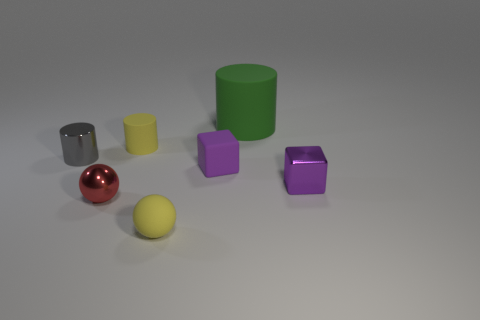Subtract all yellow rubber cylinders. How many cylinders are left? 2 Add 2 tiny purple rubber blocks. How many objects exist? 9 Subtract all blocks. How many objects are left? 5 Subtract all large rubber cylinders. Subtract all tiny metal cylinders. How many objects are left? 5 Add 1 rubber spheres. How many rubber spheres are left? 2 Add 4 metal spheres. How many metal spheres exist? 5 Subtract 1 yellow cylinders. How many objects are left? 6 